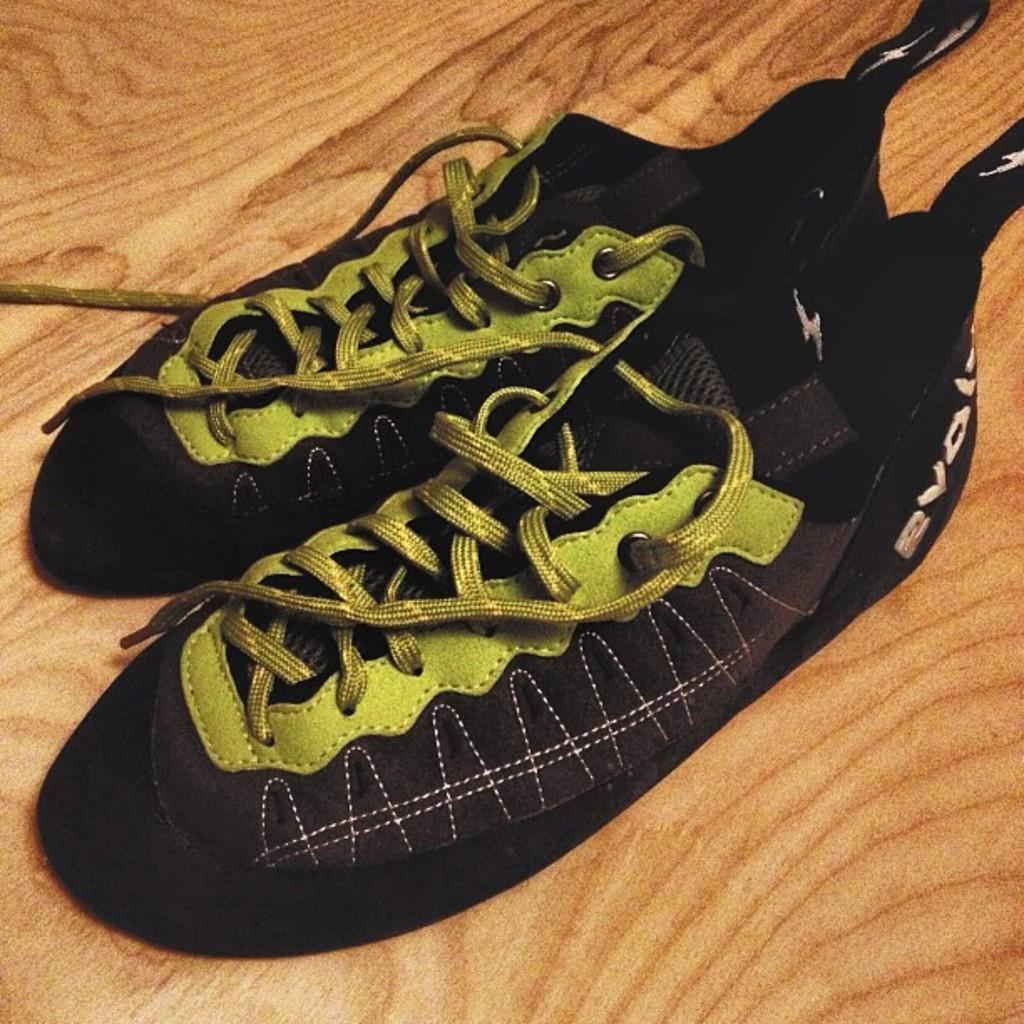What type of footwear is visible in the image? There is a pair of shoes in the image. Can you describe the surface on which the shoes are placed? The shoes are on a wooden surface. What type of animal is sitting on the desk in the image? There is no animal or desk present in the image; it only features a pair of shoes on a wooden surface. 